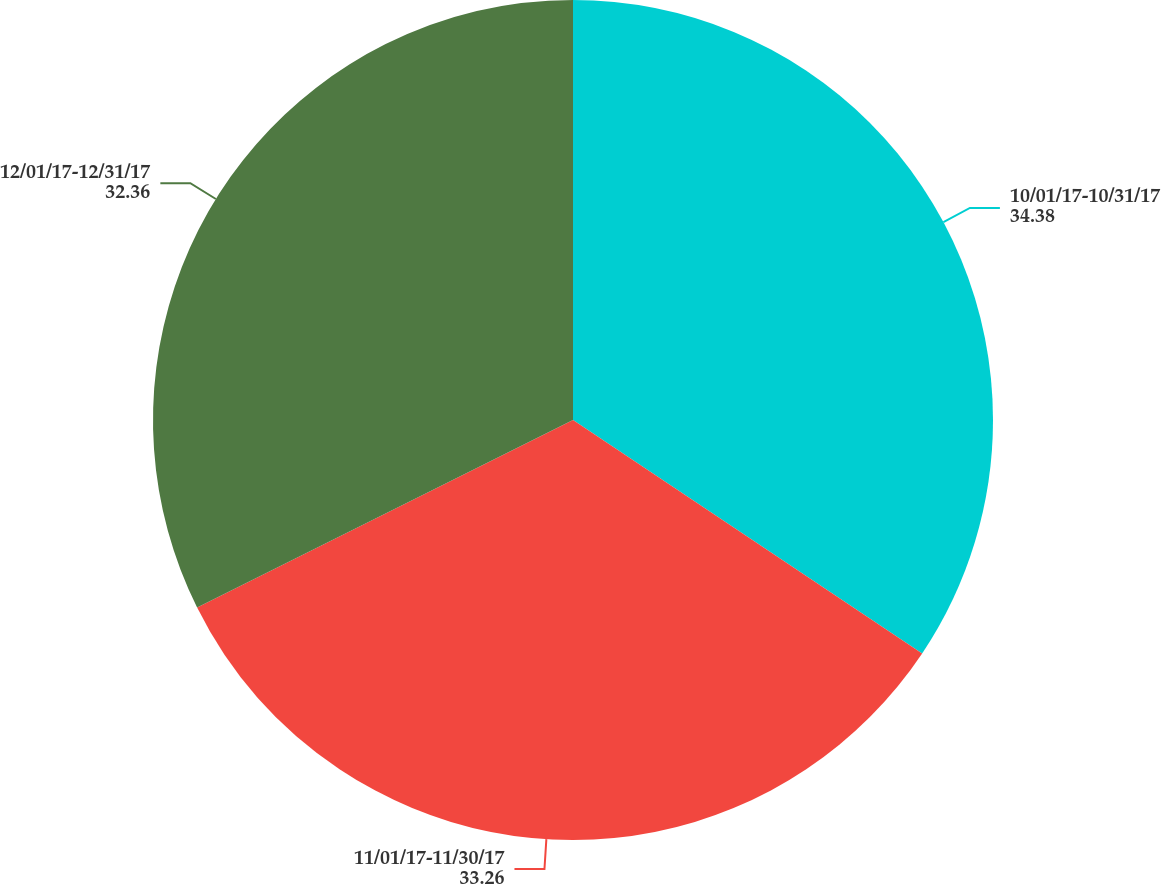Convert chart to OTSL. <chart><loc_0><loc_0><loc_500><loc_500><pie_chart><fcel>10/01/17-10/31/17<fcel>11/01/17-11/30/17<fcel>12/01/17-12/31/17<nl><fcel>34.38%<fcel>33.26%<fcel>32.36%<nl></chart> 